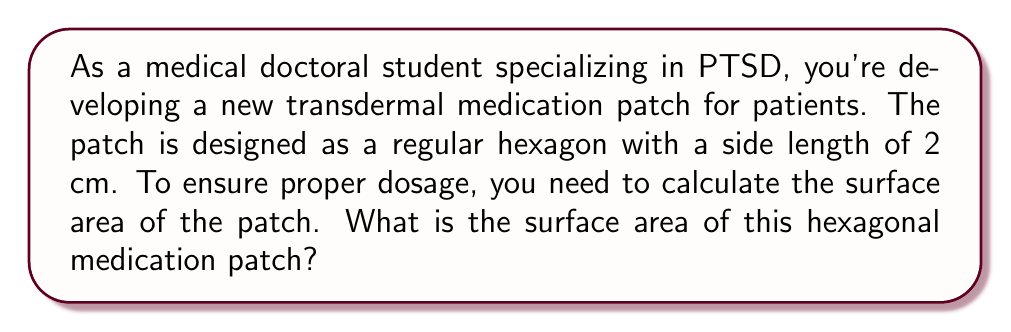Help me with this question. To calculate the surface area of a regular hexagonal patch, we need to follow these steps:

1. Recall the formula for the area of a regular hexagon:
   $$A = \frac{3\sqrt{3}}{2}a^2$$
   where $a$ is the length of one side.

2. In this case, $a = 2$ cm. Let's substitute this into the formula:
   $$A = \frac{3\sqrt{3}}{2}(2^2)$$

3. Simplify the expression inside the parentheses:
   $$A = \frac{3\sqrt{3}}{2}(4)$$

4. Multiply:
   $$A = 6\sqrt{3}$$

5. To get a decimal approximation, we can calculate $\sqrt{3}$:
   $$A \approx 6 \times 1.732050808 \approx 10.392304648$$

6. Rounding to two decimal places:
   $$A \approx 10.39 \text{ cm}^2$$

[asy]
unitsize(1cm);
pair A = (0,0);
pair B = (2,0);
pair C = (3,sqrt(3));
pair D = (2,2*sqrt(3));
pair E = (0,2*sqrt(3));
pair F = (-1,sqrt(3));
draw(A--B--C--D--E--F--cycle);
label("2 cm", (A+B)/2, S);
[/asy]
Answer: The surface area of the hexagonal medication patch is $6\sqrt{3} \approx 10.39 \text{ cm}^2$. 